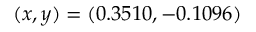<formula> <loc_0><loc_0><loc_500><loc_500>( x , y ) = ( 0 . 3 5 1 0 , - 0 . 1 0 9 6 )</formula> 